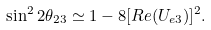<formula> <loc_0><loc_0><loc_500><loc_500>\sin ^ { 2 } 2 \theta _ { 2 3 } \simeq 1 - 8 [ R e ( U _ { e 3 } ) ] ^ { 2 } .</formula> 